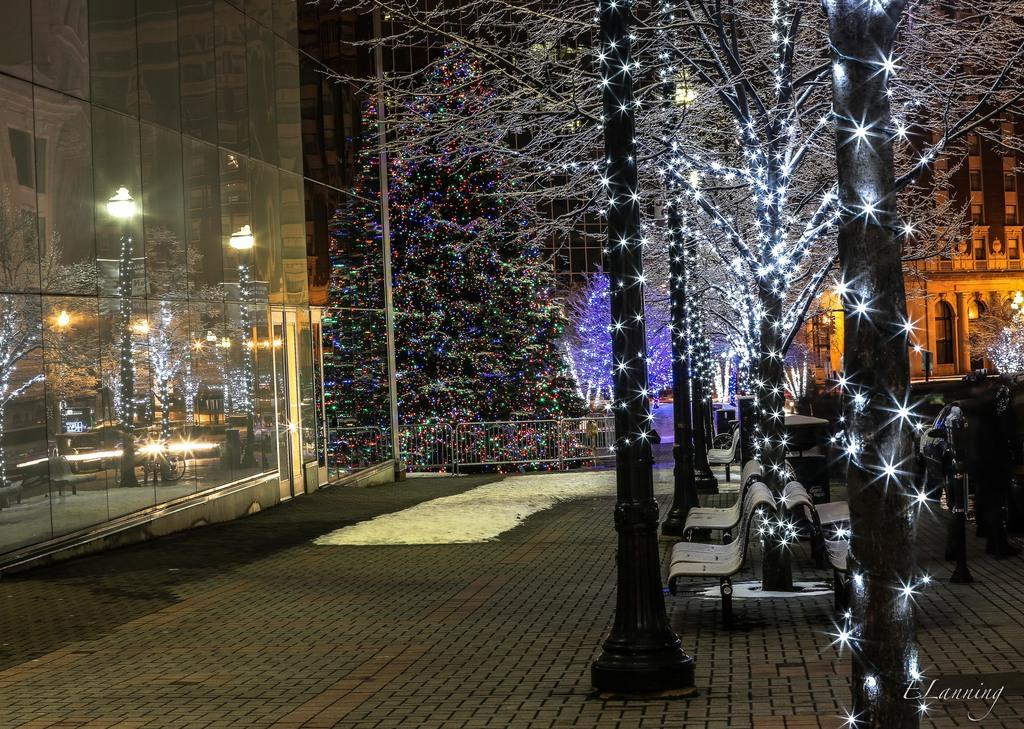What type of vegetation can be seen in the image? There are trees in the image. How are the trees decorated in the image? The trees are decorated with lights. What other structures are decorated with lights in the image? The poles are also decorated with lights. What type of seating is available in the image? There are benches in the image. What type of man-made structures are visible in the image? There are buildings in the image. What type of barrier is present in the image? There is a fence in the image. What other objects can be found on the ground in the image? There are other objects on the ground in the image. Can you see a ship sailing on the sea in the image? There is no ship or sea present in the image. How are the clothes being washed in the image? There is no washing or laundry depicted in the image. 